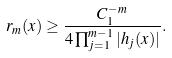<formula> <loc_0><loc_0><loc_500><loc_500>r _ { m } ( x ) \geq \frac { C _ { 1 } ^ { - m } } { 4 \prod _ { j = 1 } ^ { m - 1 } | h _ { j } ( x ) | } .</formula> 